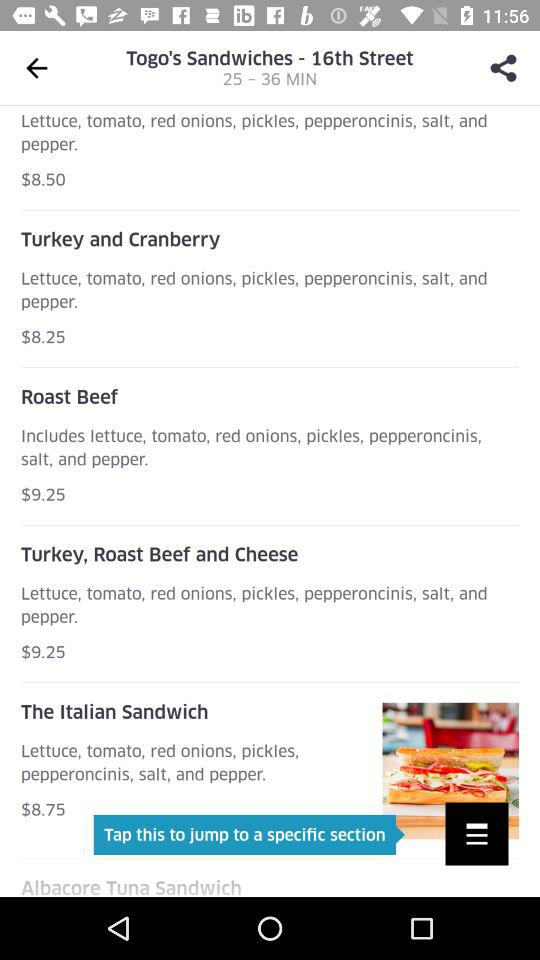What is the name of the $8.25 dish? The dish's name is "Turkey and Cranberry". 